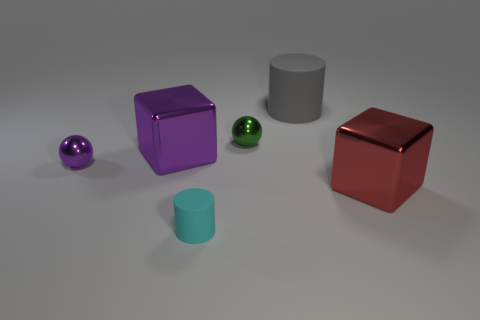Subtract all purple balls. How many balls are left? 1 Subtract all spheres. How many objects are left? 4 Add 1 large purple metal cylinders. How many objects exist? 7 Subtract 1 balls. How many balls are left? 1 Subtract 0 blue spheres. How many objects are left? 6 Subtract all green cylinders. Subtract all brown spheres. How many cylinders are left? 2 Subtract all big yellow spheres. Subtract all tiny cyan matte cylinders. How many objects are left? 5 Add 3 balls. How many balls are left? 5 Add 6 brown metal cylinders. How many brown metal cylinders exist? 6 